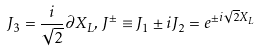<formula> <loc_0><loc_0><loc_500><loc_500>J _ { 3 } = \frac { i } { \sqrt { 2 } } \partial X _ { L } , \, J ^ { \pm } \equiv J _ { 1 } \pm i J _ { 2 } = e ^ { \pm i \sqrt { 2 } X _ { L } }</formula> 